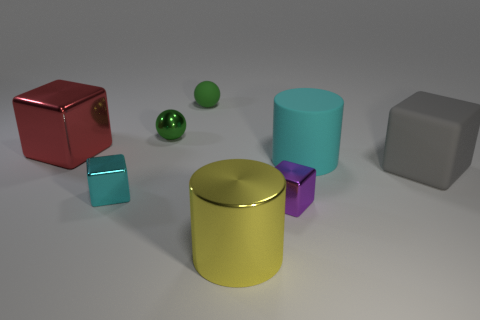Can you describe the physical properties of the objects in the image? Certainly! The objects in the image have a variety of shapes, including cubes, spheres, and cylinders. Their surfaces appear smooth, with some having a glossy finish that reflects light, suggesting they are made from materials like plastic or polished metal. The lighting indicates a soft ambient source, possibly meant to highlight the objects' reflective properties without causing harsh shadows. 